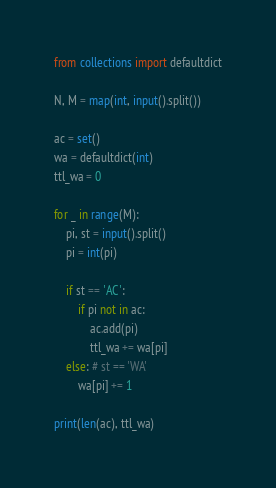Convert code to text. <code><loc_0><loc_0><loc_500><loc_500><_Python_>from collections import defaultdict

N, M = map(int, input().split())

ac = set()
wa = defaultdict(int)
ttl_wa = 0

for _ in range(M):
    pi, st = input().split()
    pi = int(pi)

    if st == 'AC':
        if pi not in ac:
            ac.add(pi)
            ttl_wa += wa[pi]
    else: # st == 'WA'
        wa[pi] += 1

print(len(ac), ttl_wa)
</code> 